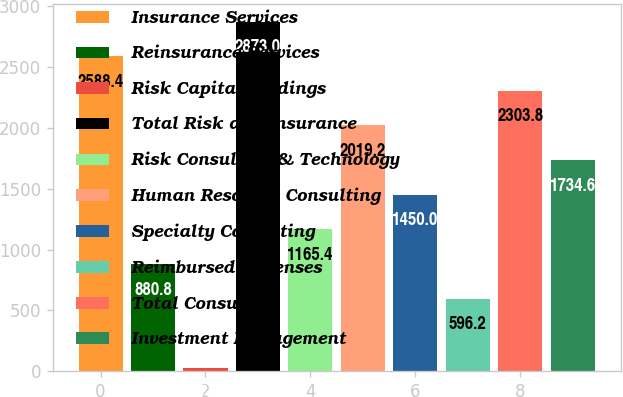Convert chart. <chart><loc_0><loc_0><loc_500><loc_500><bar_chart><fcel>Insurance Services<fcel>Reinsurance Services<fcel>Risk Capital Holdings<fcel>Total Risk and Insurance<fcel>Risk Consulting & Technology<fcel>Human Resource Consulting<fcel>Specialty Consulting<fcel>Reimbursed Expenses<fcel>Total Consulting<fcel>Investment Management<nl><fcel>2588.4<fcel>880.8<fcel>27<fcel>2873<fcel>1165.4<fcel>2019.2<fcel>1450<fcel>596.2<fcel>2303.8<fcel>1734.6<nl></chart> 